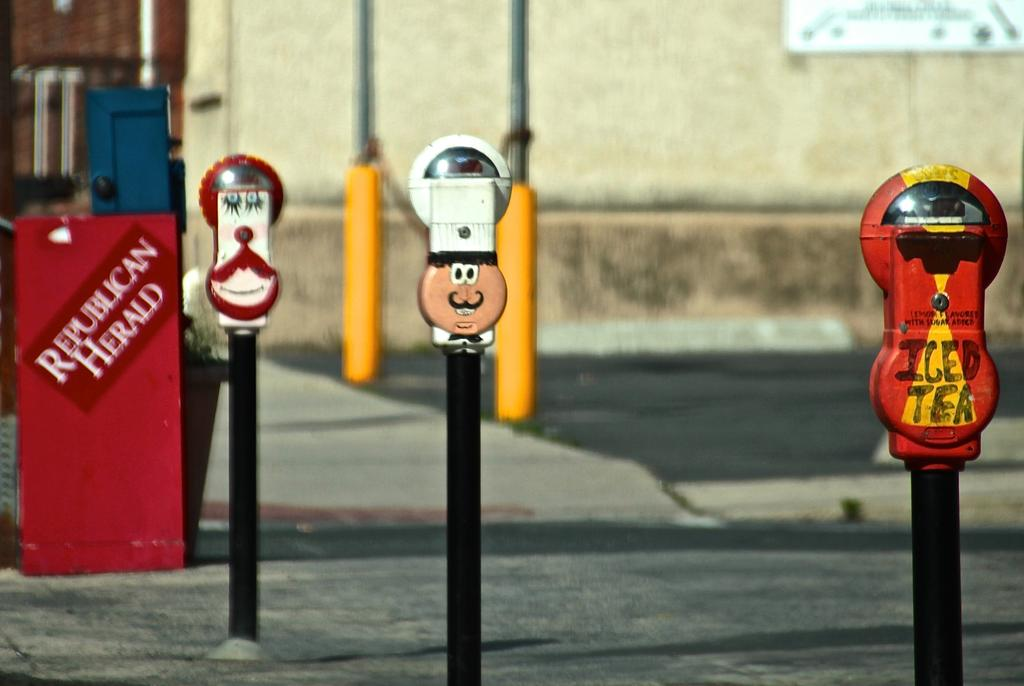<image>
Share a concise interpretation of the image provided. Several funny parking meters are installed near a Republican Herald newspaper box. 